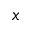Convert formula to latex. <formula><loc_0><loc_0><loc_500><loc_500>x</formula> 